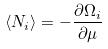Convert formula to latex. <formula><loc_0><loc_0><loc_500><loc_500>\langle N _ { i } \rangle = - \frac { \partial \Omega _ { i } } { \partial \mu }</formula> 